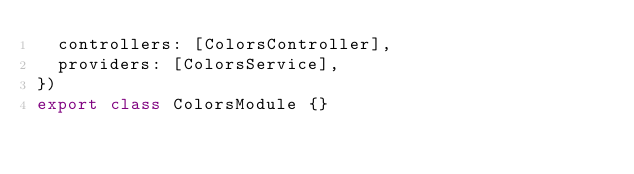Convert code to text. <code><loc_0><loc_0><loc_500><loc_500><_TypeScript_>  controllers: [ColorsController],
  providers: [ColorsService],
})
export class ColorsModule {}
</code> 